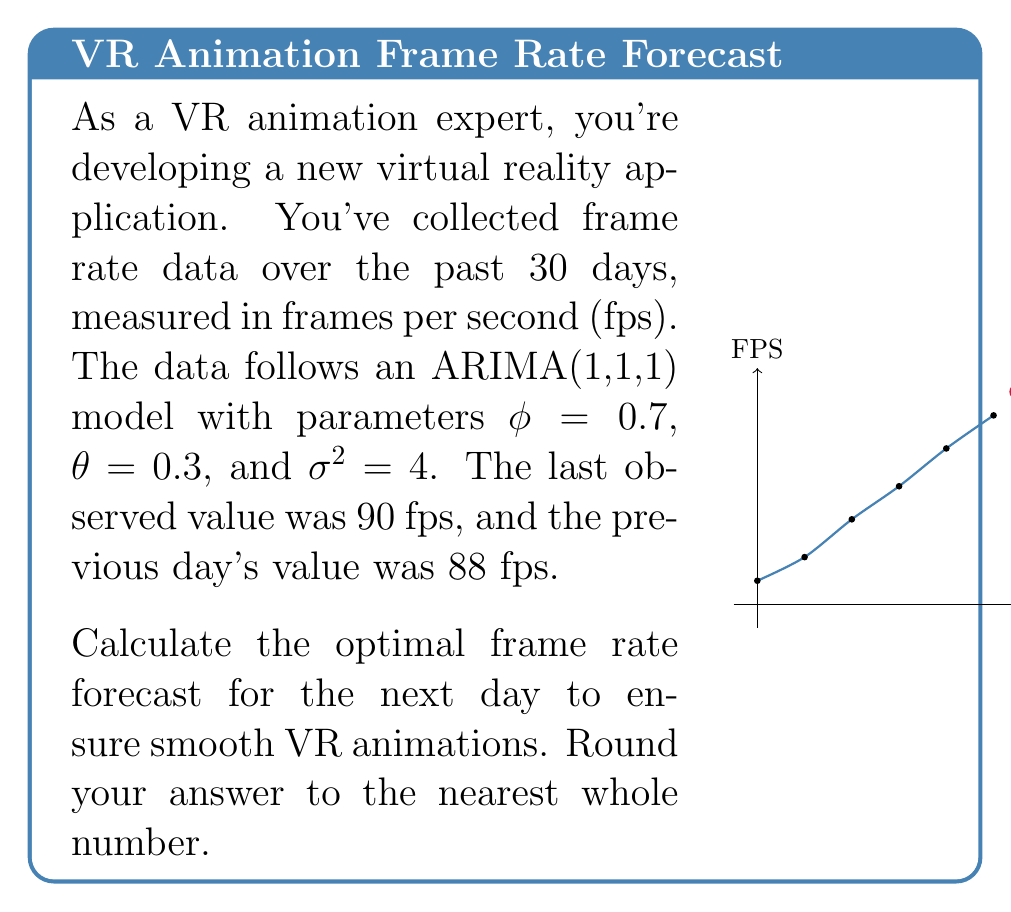Give your solution to this math problem. To solve this problem, we'll use the ARIMA(1,1,1) model to forecast the next frame rate. Let's break it down step-by-step:

1) The ARIMA(1,1,1) model can be written as:

   $$(1 - \phi B)(1 - B)X_t = (1 + \theta B)\epsilon_t$$

   where $B$ is the backshift operator, $X_t$ is the time series, and $\epsilon_t$ is white noise.

2) Expanding this, we get:

   $$X_t = X_{t-1} + \phi(X_{t-1} - X_{t-2}) + \epsilon_t + \theta\epsilon_{t-1}$$

3) For forecasting one step ahead, we use the expectation:

   $$\hat{X}_{t+1} = X_t + \phi(X_t - X_{t-1}) + \theta\epsilon_t$$

4) We know:
   - $X_t = 90$ (last observed value)
   - $X_{t-1} = 88$ (previous day's value)
   - $\phi = 0.7$
   - $\theta = 0.3$

5) We need to estimate $\epsilon_t$. In an ARIMA(1,1,1) model:

   $$\epsilon_t = X_t - X_{t-1} - \phi(X_{t-1} - X_{t-2}) - \theta\epsilon_{t-1}$$

   We don't know $X_{t-2}$ or $\epsilon_{t-1}$, so we'll approximate $\epsilon_t$ as:

   $$\epsilon_t \approx X_t - X_{t-1} = 90 - 88 = 2$$

6) Now we can calculate the forecast:

   $$\hat{X}_{t+1} = 90 + 0.7(90 - 88) + 0.3(2)$$
   $$= 90 + 1.4 + 0.6$$
   $$= 92$$

7) Rounding to the nearest whole number, we get 92 fps.
Answer: 92 fps 